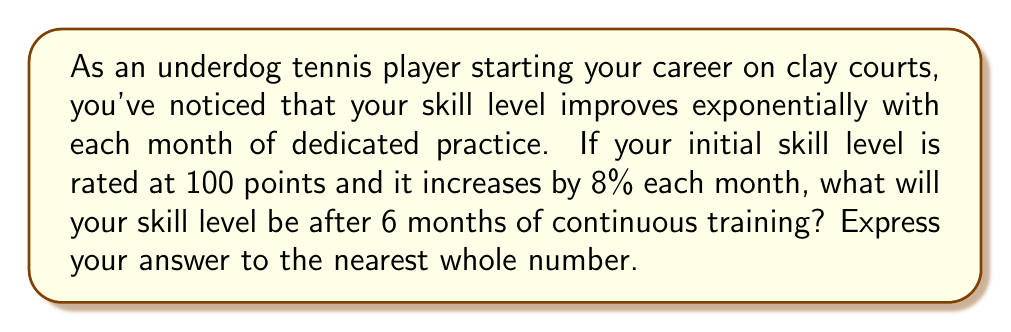Teach me how to tackle this problem. Let's approach this step-by-step using the exponential growth formula:

$A = P(1 + r)^t$

Where:
$A$ = Final amount
$P$ = Initial principal balance
$r$ = Growth rate (as a decimal)
$t$ = Time periods elapsed

Given:
$P = 100$ (initial skill level)
$r = 0.08$ (8% growth rate)
$t = 6$ (months)

Let's plug these values into our formula:

$A = 100(1 + 0.08)^6$

Now, let's calculate:

$A = 100(1.08)^6$

$A = 100 * 1.5869784$

$A = 158.69784$

Rounding to the nearest whole number:

$A \approx 159$
Answer: 159 